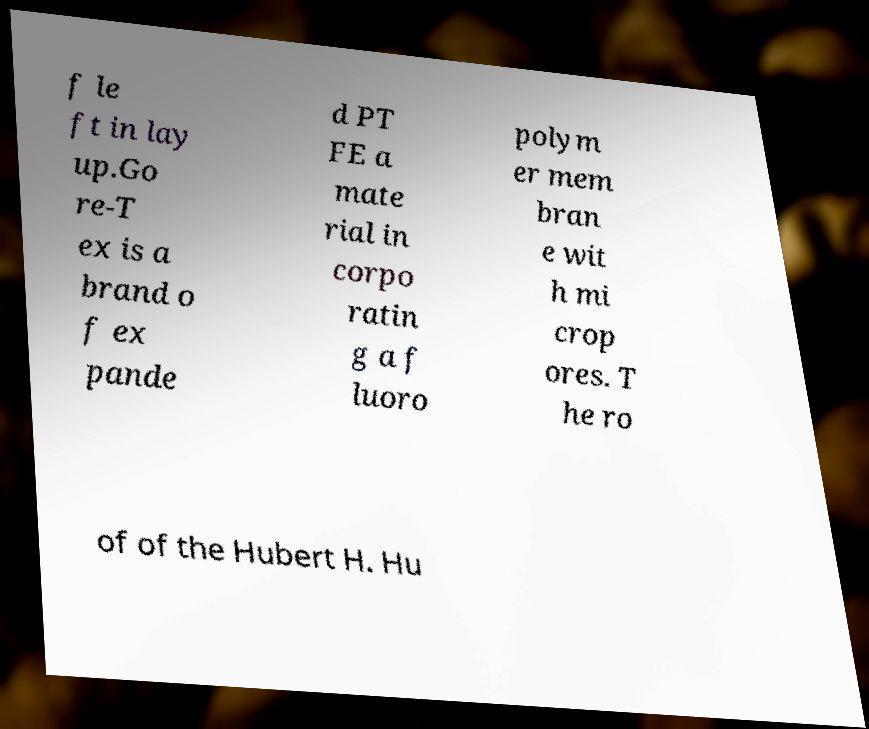I need the written content from this picture converted into text. Can you do that? f le ft in lay up.Go re-T ex is a brand o f ex pande d PT FE a mate rial in corpo ratin g a f luoro polym er mem bran e wit h mi crop ores. T he ro of of the Hubert H. Hu 